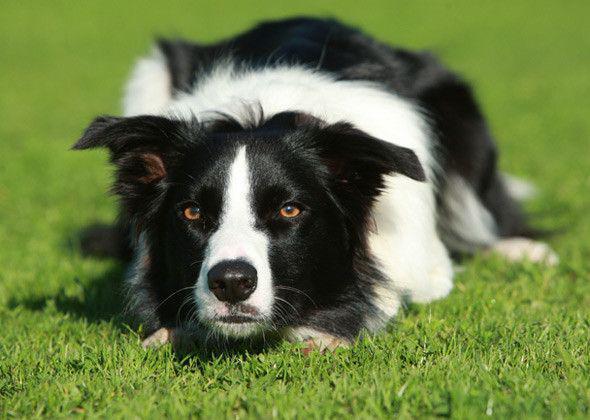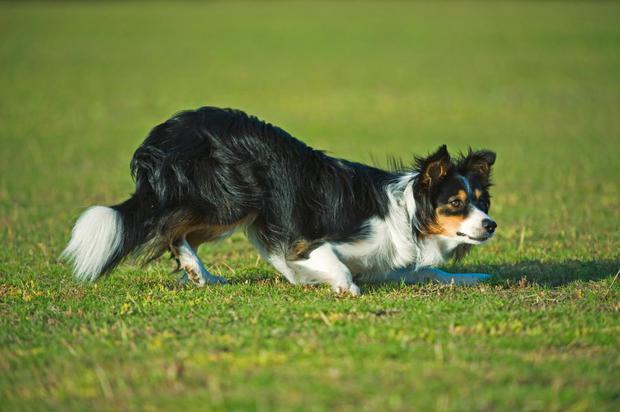The first image is the image on the left, the second image is the image on the right. Examine the images to the left and right. Is the description "The right image shows a border collie hunched near the ground and facing right." accurate? Answer yes or no. Yes. 